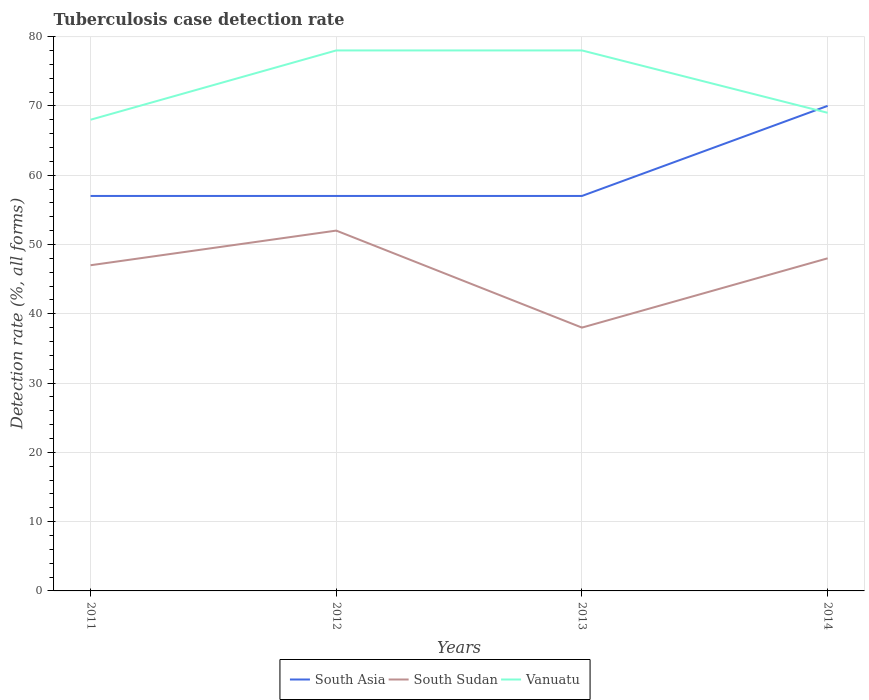Across all years, what is the maximum tuberculosis case detection rate in in South Asia?
Provide a succinct answer. 57. What is the total tuberculosis case detection rate in in South Asia in the graph?
Give a very brief answer. -13. What is the difference between the highest and the second highest tuberculosis case detection rate in in Vanuatu?
Your response must be concise. 10. How many lines are there?
Ensure brevity in your answer.  3. How many years are there in the graph?
Offer a very short reply. 4. Does the graph contain any zero values?
Your response must be concise. No. Does the graph contain grids?
Give a very brief answer. Yes. What is the title of the graph?
Offer a very short reply. Tuberculosis case detection rate. What is the label or title of the Y-axis?
Your answer should be very brief. Detection rate (%, all forms). What is the Detection rate (%, all forms) of South Asia in 2011?
Keep it short and to the point. 57. What is the Detection rate (%, all forms) of South Asia in 2012?
Make the answer very short. 57. What is the Detection rate (%, all forms) of Vanuatu in 2012?
Your answer should be compact. 78. What is the Detection rate (%, all forms) in South Asia in 2013?
Offer a very short reply. 57. What is the Detection rate (%, all forms) of South Sudan in 2013?
Provide a short and direct response. 38. What is the Detection rate (%, all forms) in Vanuatu in 2013?
Your answer should be compact. 78. What is the Detection rate (%, all forms) of South Asia in 2014?
Offer a terse response. 70. Across all years, what is the minimum Detection rate (%, all forms) in Vanuatu?
Provide a succinct answer. 68. What is the total Detection rate (%, all forms) of South Asia in the graph?
Your answer should be compact. 241. What is the total Detection rate (%, all forms) of South Sudan in the graph?
Offer a very short reply. 185. What is the total Detection rate (%, all forms) of Vanuatu in the graph?
Keep it short and to the point. 293. What is the difference between the Detection rate (%, all forms) in South Asia in 2011 and that in 2012?
Make the answer very short. 0. What is the difference between the Detection rate (%, all forms) in South Sudan in 2011 and that in 2012?
Ensure brevity in your answer.  -5. What is the difference between the Detection rate (%, all forms) of South Asia in 2011 and that in 2013?
Ensure brevity in your answer.  0. What is the difference between the Detection rate (%, all forms) in South Sudan in 2011 and that in 2013?
Give a very brief answer. 9. What is the difference between the Detection rate (%, all forms) of Vanuatu in 2011 and that in 2013?
Ensure brevity in your answer.  -10. What is the difference between the Detection rate (%, all forms) of South Sudan in 2011 and that in 2014?
Ensure brevity in your answer.  -1. What is the difference between the Detection rate (%, all forms) of South Asia in 2012 and that in 2013?
Offer a terse response. 0. What is the difference between the Detection rate (%, all forms) in South Sudan in 2012 and that in 2013?
Your response must be concise. 14. What is the difference between the Detection rate (%, all forms) in South Asia in 2012 and that in 2014?
Your answer should be compact. -13. What is the difference between the Detection rate (%, all forms) of South Sudan in 2012 and that in 2014?
Your response must be concise. 4. What is the difference between the Detection rate (%, all forms) of Vanuatu in 2012 and that in 2014?
Give a very brief answer. 9. What is the difference between the Detection rate (%, all forms) in South Sudan in 2013 and that in 2014?
Ensure brevity in your answer.  -10. What is the difference between the Detection rate (%, all forms) in Vanuatu in 2013 and that in 2014?
Your answer should be very brief. 9. What is the difference between the Detection rate (%, all forms) in South Asia in 2011 and the Detection rate (%, all forms) in South Sudan in 2012?
Ensure brevity in your answer.  5. What is the difference between the Detection rate (%, all forms) in South Sudan in 2011 and the Detection rate (%, all forms) in Vanuatu in 2012?
Provide a succinct answer. -31. What is the difference between the Detection rate (%, all forms) in South Asia in 2011 and the Detection rate (%, all forms) in South Sudan in 2013?
Provide a short and direct response. 19. What is the difference between the Detection rate (%, all forms) in South Asia in 2011 and the Detection rate (%, all forms) in Vanuatu in 2013?
Give a very brief answer. -21. What is the difference between the Detection rate (%, all forms) of South Sudan in 2011 and the Detection rate (%, all forms) of Vanuatu in 2013?
Your answer should be very brief. -31. What is the difference between the Detection rate (%, all forms) of South Asia in 2011 and the Detection rate (%, all forms) of South Sudan in 2014?
Make the answer very short. 9. What is the difference between the Detection rate (%, all forms) in South Sudan in 2011 and the Detection rate (%, all forms) in Vanuatu in 2014?
Your response must be concise. -22. What is the difference between the Detection rate (%, all forms) of South Asia in 2012 and the Detection rate (%, all forms) of Vanuatu in 2013?
Offer a terse response. -21. What is the difference between the Detection rate (%, all forms) in South Sudan in 2012 and the Detection rate (%, all forms) in Vanuatu in 2013?
Your answer should be compact. -26. What is the difference between the Detection rate (%, all forms) in South Sudan in 2012 and the Detection rate (%, all forms) in Vanuatu in 2014?
Provide a succinct answer. -17. What is the difference between the Detection rate (%, all forms) of South Asia in 2013 and the Detection rate (%, all forms) of South Sudan in 2014?
Keep it short and to the point. 9. What is the difference between the Detection rate (%, all forms) of South Asia in 2013 and the Detection rate (%, all forms) of Vanuatu in 2014?
Your answer should be compact. -12. What is the difference between the Detection rate (%, all forms) in South Sudan in 2013 and the Detection rate (%, all forms) in Vanuatu in 2014?
Offer a terse response. -31. What is the average Detection rate (%, all forms) in South Asia per year?
Make the answer very short. 60.25. What is the average Detection rate (%, all forms) of South Sudan per year?
Give a very brief answer. 46.25. What is the average Detection rate (%, all forms) of Vanuatu per year?
Your answer should be very brief. 73.25. In the year 2011, what is the difference between the Detection rate (%, all forms) of South Sudan and Detection rate (%, all forms) of Vanuatu?
Your answer should be compact. -21. In the year 2012, what is the difference between the Detection rate (%, all forms) in South Asia and Detection rate (%, all forms) in South Sudan?
Ensure brevity in your answer.  5. In the year 2013, what is the difference between the Detection rate (%, all forms) of South Asia and Detection rate (%, all forms) of Vanuatu?
Your answer should be compact. -21. In the year 2014, what is the difference between the Detection rate (%, all forms) of South Asia and Detection rate (%, all forms) of Vanuatu?
Provide a succinct answer. 1. In the year 2014, what is the difference between the Detection rate (%, all forms) in South Sudan and Detection rate (%, all forms) in Vanuatu?
Your answer should be compact. -21. What is the ratio of the Detection rate (%, all forms) in South Asia in 2011 to that in 2012?
Your answer should be compact. 1. What is the ratio of the Detection rate (%, all forms) of South Sudan in 2011 to that in 2012?
Provide a succinct answer. 0.9. What is the ratio of the Detection rate (%, all forms) in Vanuatu in 2011 to that in 2012?
Offer a very short reply. 0.87. What is the ratio of the Detection rate (%, all forms) of South Sudan in 2011 to that in 2013?
Provide a short and direct response. 1.24. What is the ratio of the Detection rate (%, all forms) in Vanuatu in 2011 to that in 2013?
Your answer should be very brief. 0.87. What is the ratio of the Detection rate (%, all forms) in South Asia in 2011 to that in 2014?
Offer a very short reply. 0.81. What is the ratio of the Detection rate (%, all forms) of South Sudan in 2011 to that in 2014?
Make the answer very short. 0.98. What is the ratio of the Detection rate (%, all forms) of Vanuatu in 2011 to that in 2014?
Keep it short and to the point. 0.99. What is the ratio of the Detection rate (%, all forms) in South Asia in 2012 to that in 2013?
Your answer should be compact. 1. What is the ratio of the Detection rate (%, all forms) in South Sudan in 2012 to that in 2013?
Make the answer very short. 1.37. What is the ratio of the Detection rate (%, all forms) in Vanuatu in 2012 to that in 2013?
Ensure brevity in your answer.  1. What is the ratio of the Detection rate (%, all forms) of South Asia in 2012 to that in 2014?
Your response must be concise. 0.81. What is the ratio of the Detection rate (%, all forms) of Vanuatu in 2012 to that in 2014?
Give a very brief answer. 1.13. What is the ratio of the Detection rate (%, all forms) of South Asia in 2013 to that in 2014?
Ensure brevity in your answer.  0.81. What is the ratio of the Detection rate (%, all forms) in South Sudan in 2013 to that in 2014?
Your response must be concise. 0.79. What is the ratio of the Detection rate (%, all forms) in Vanuatu in 2013 to that in 2014?
Provide a short and direct response. 1.13. What is the difference between the highest and the second highest Detection rate (%, all forms) of South Asia?
Provide a short and direct response. 13. What is the difference between the highest and the second highest Detection rate (%, all forms) of South Sudan?
Offer a terse response. 4. What is the difference between the highest and the second highest Detection rate (%, all forms) of Vanuatu?
Offer a very short reply. 0. What is the difference between the highest and the lowest Detection rate (%, all forms) of South Asia?
Your answer should be compact. 13. 